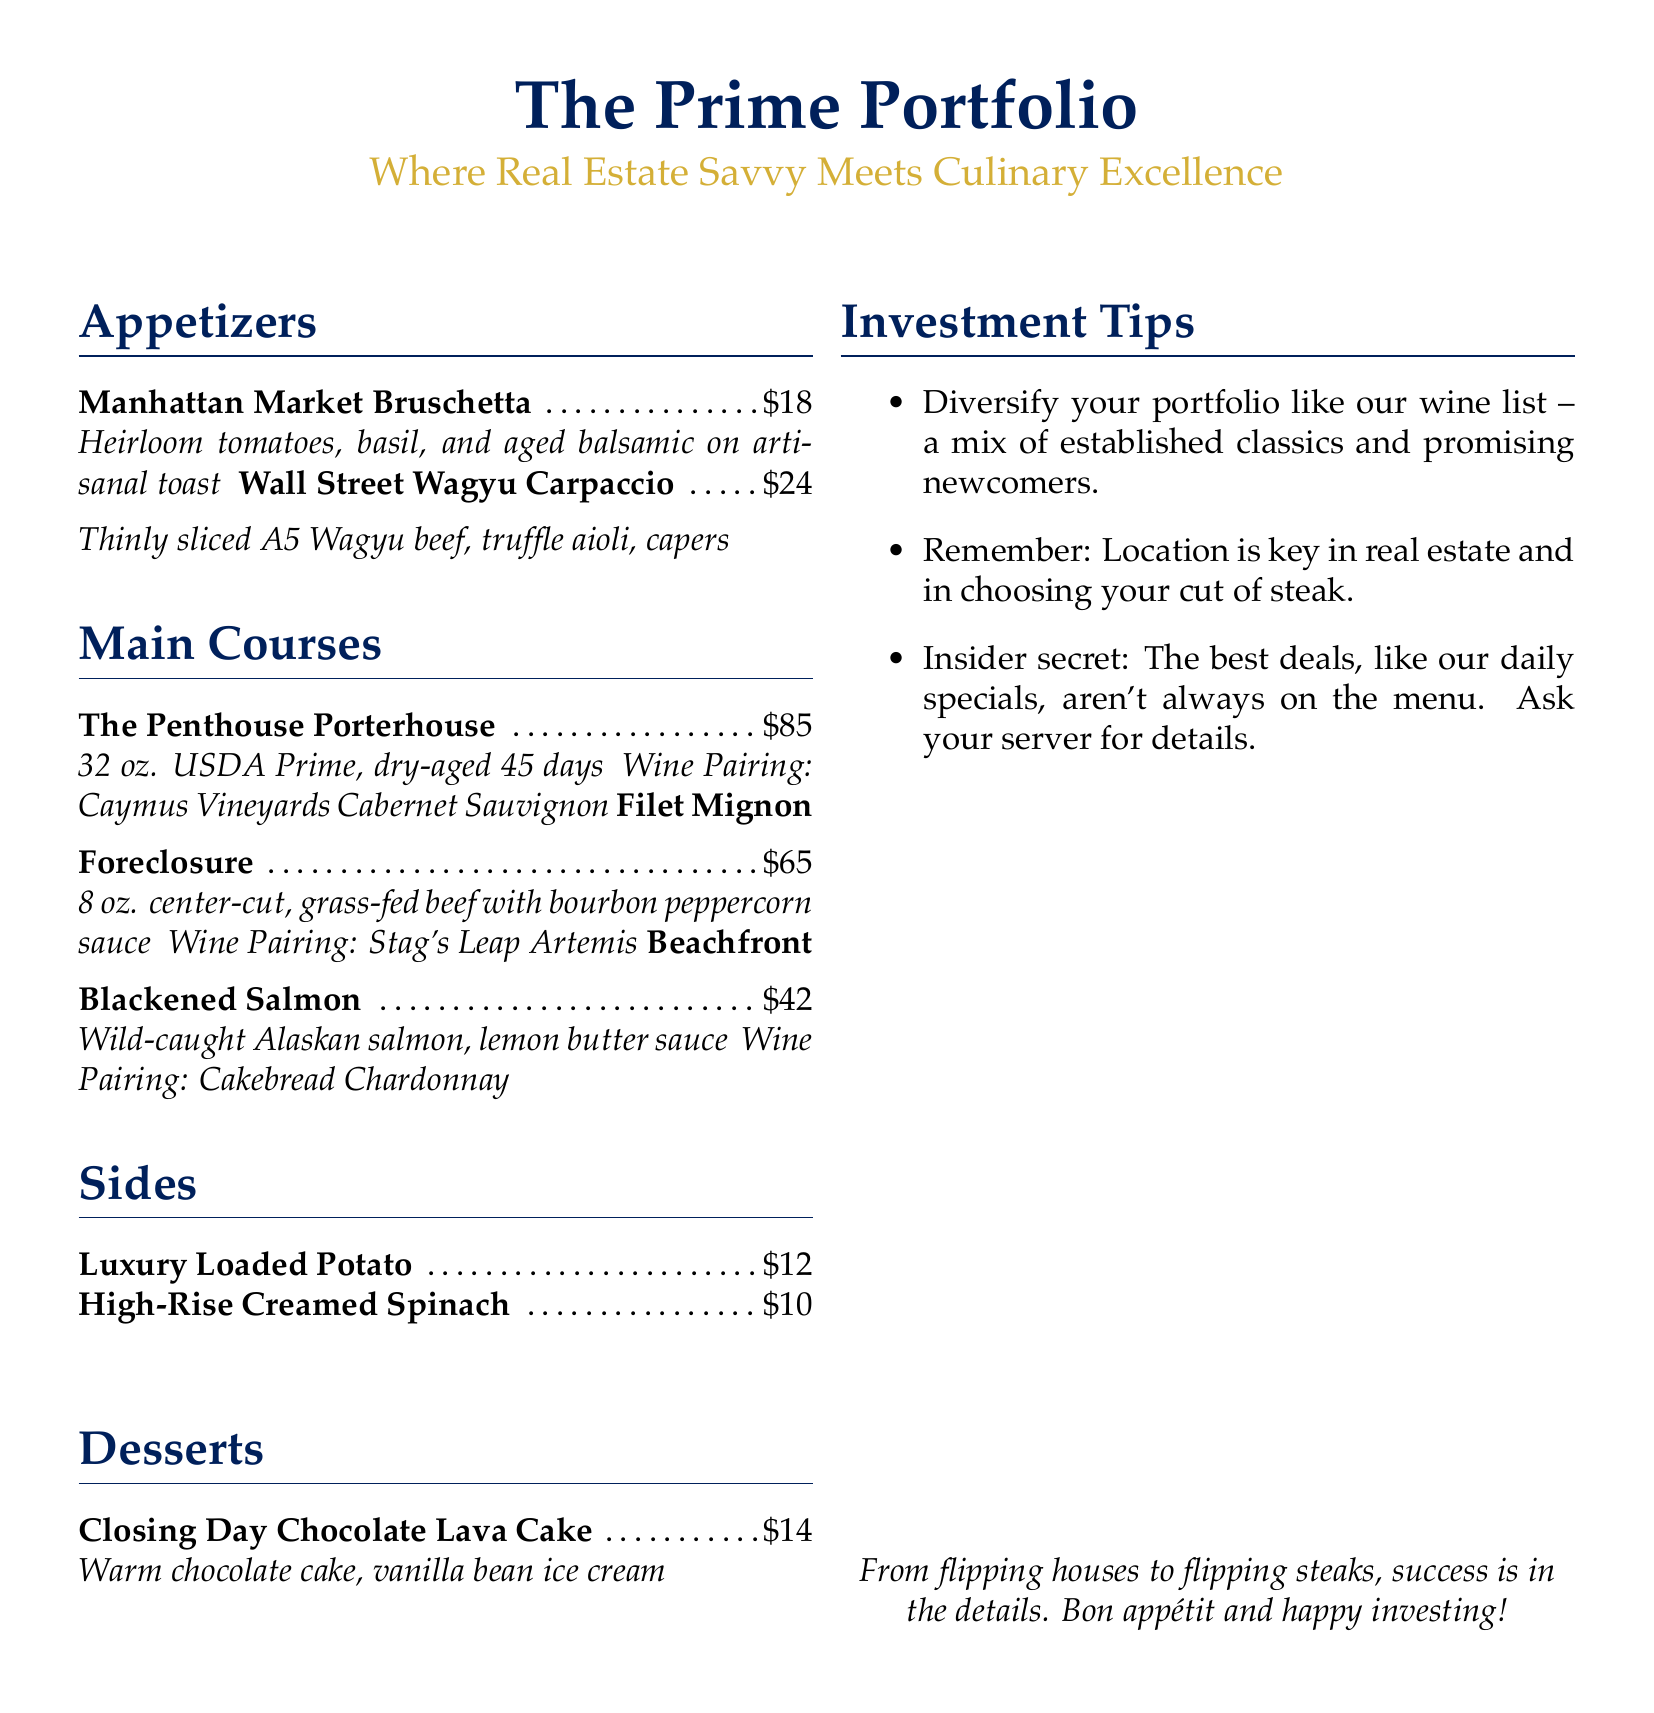What is the name of the appetizer that features heirloom tomatoes? The appetizer with heirloom tomatoes is listed as "Manhattan Market Bruschetta."
Answer: Manhattan Market Bruschetta How much does the Penthouse Porterhouse cost? The document specifies that the cost of the Penthouse Porterhouse is $85.
Answer: $85 What wine is paired with the Filet Mignon Foreclosure? The wine pairing for the Filet Mignon Foreclosure is "Stag's Leap Artemis."
Answer: Stag's Leap Artemis What is one investment tip mentioned in the menu? One of the investment tips provided is to "Diversify your portfolio like our wine list."
Answer: Diversify your portfolio like our wine list What is the dessert that features chocolate lava? The dessert with chocolate lava is called "Closing Day Chocolate Lava Cake."
Answer: Closing Day Chocolate Lava Cake How much is the Luxury Loaded Potato? The document indicates that the Luxury Loaded Potato costs $12.
Answer: $12 What is suggested to be key in both real estate and choosing a cut of steak? The menu suggests that "Location is key."
Answer: Location is key How many ounces is the Porterhouse steak? The Porterhouse steak is specified as 32 ounces in the menu.
Answer: 32 oz 